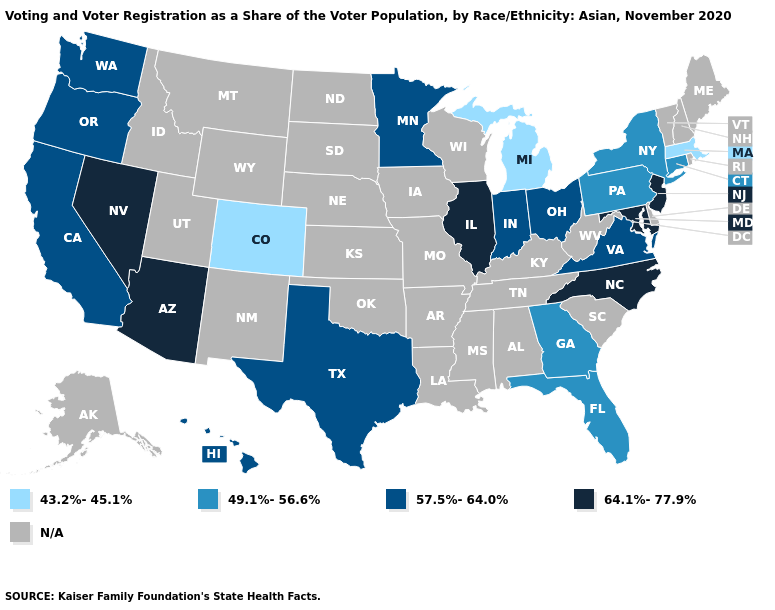What is the highest value in the West ?
Give a very brief answer. 64.1%-77.9%. What is the lowest value in states that border Michigan?
Be succinct. 57.5%-64.0%. What is the highest value in states that border South Carolina?
Give a very brief answer. 64.1%-77.9%. Among the states that border Georgia , does North Carolina have the highest value?
Concise answer only. Yes. What is the value of Oregon?
Write a very short answer. 57.5%-64.0%. What is the value of Wisconsin?
Give a very brief answer. N/A. What is the value of Massachusetts?
Write a very short answer. 43.2%-45.1%. Which states have the lowest value in the USA?
Short answer required. Colorado, Massachusetts, Michigan. Name the states that have a value in the range N/A?
Be succinct. Alabama, Alaska, Arkansas, Delaware, Idaho, Iowa, Kansas, Kentucky, Louisiana, Maine, Mississippi, Missouri, Montana, Nebraska, New Hampshire, New Mexico, North Dakota, Oklahoma, Rhode Island, South Carolina, South Dakota, Tennessee, Utah, Vermont, West Virginia, Wisconsin, Wyoming. Is the legend a continuous bar?
Quick response, please. No. Name the states that have a value in the range 43.2%-45.1%?
Short answer required. Colorado, Massachusetts, Michigan. What is the value of New Jersey?
Write a very short answer. 64.1%-77.9%. Which states hav the highest value in the MidWest?
Keep it brief. Illinois. What is the value of Arizona?
Give a very brief answer. 64.1%-77.9%. Name the states that have a value in the range 49.1%-56.6%?
Write a very short answer. Connecticut, Florida, Georgia, New York, Pennsylvania. 